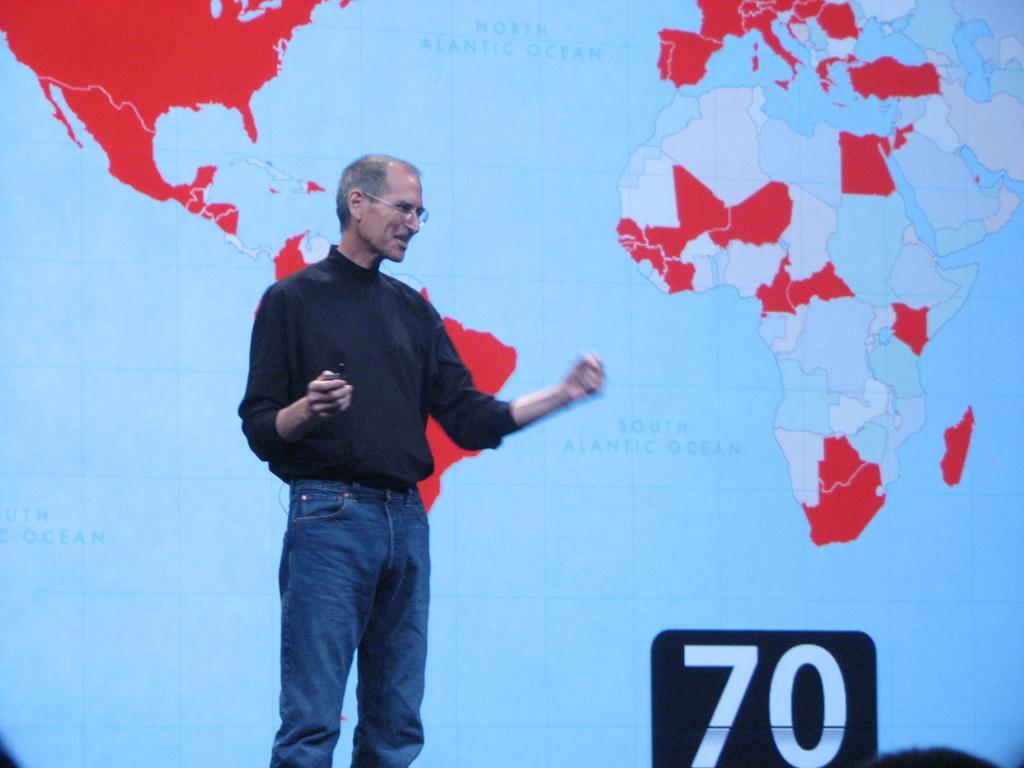How would you summarize this image in a sentence or two? In this image we can see a person standing and holding an object, in the background, we can see a screen with maps and on the right side of the image we can see a number seventy. 